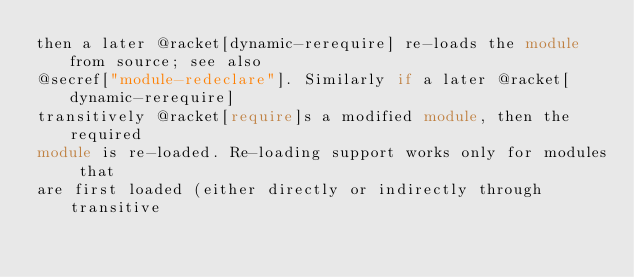<code> <loc_0><loc_0><loc_500><loc_500><_Racket_>then a later @racket[dynamic-rerequire] re-loads the module from source; see also
@secref["module-redeclare"]. Similarly if a later @racket[dynamic-rerequire]
transitively @racket[require]s a modified module, then the required
module is re-loaded. Re-loading support works only for modules that
are first loaded (either directly or indirectly through transitive</code> 